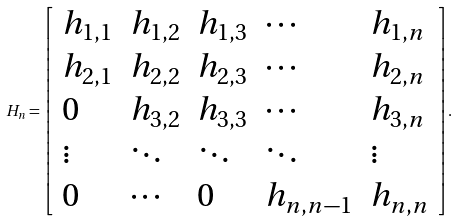<formula> <loc_0><loc_0><loc_500><loc_500>H _ { n } = { \left [ \begin{array} { l l l l l } { h _ { 1 , 1 } } & { h _ { 1 , 2 } } & { h _ { 1 , 3 } } & { \cdots } & { h _ { 1 , n } } \\ { h _ { 2 , 1 } } & { h _ { 2 , 2 } } & { h _ { 2 , 3 } } & { \cdots } & { h _ { 2 , n } } \\ { 0 } & { h _ { 3 , 2 } } & { h _ { 3 , 3 } } & { \cdots } & { h _ { 3 , n } } \\ { \vdots } & { \ddots } & { \ddots } & { \ddots } & { \vdots } \\ { 0 } & { \cdots } & { 0 } & { h _ { n , n - 1 } } & { h _ { n , n } } \end{array} \right ] } .</formula> 